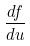Convert formula to latex. <formula><loc_0><loc_0><loc_500><loc_500>\frac { d f } { d u }</formula> 